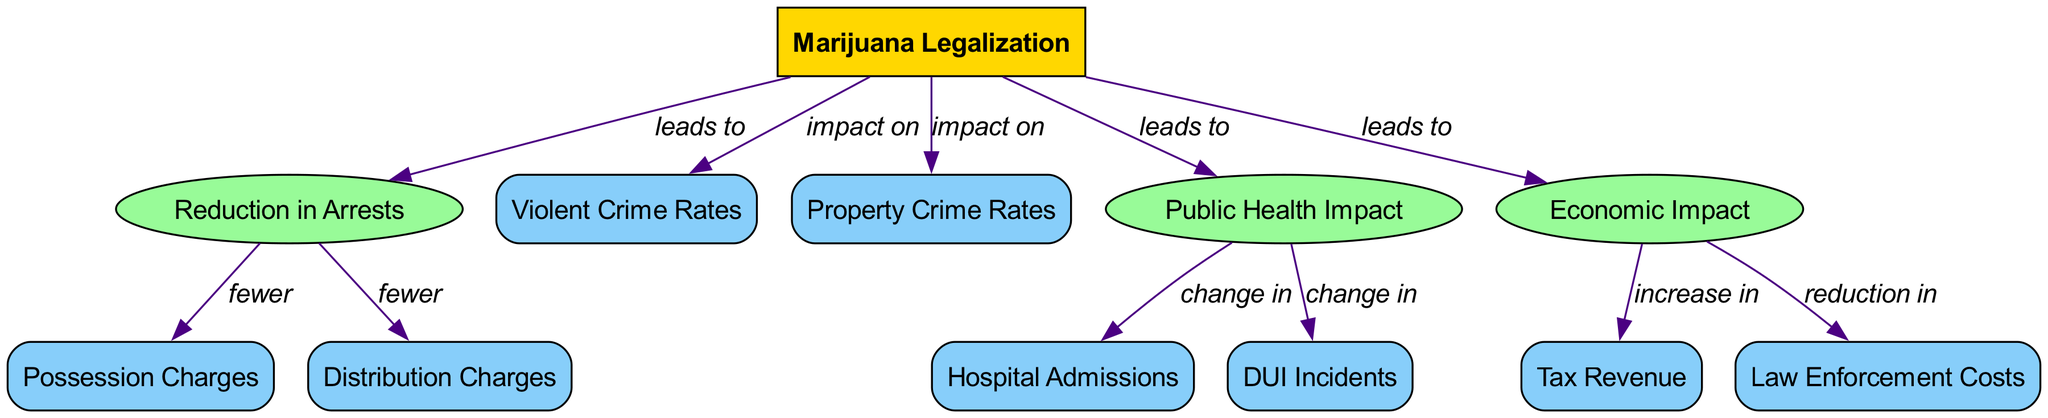What is the main topic of the diagram? The main topic is indicated as "Marijuana Legalization," which is the starting point from where all the other nodes stem. It is visually separated from other nodes that show consequences and data related to the impacts of legalization.
Answer: Marijuana Legalization How many consequences are linked to marijuana legalization? By examining the diagram, we can see three key consequences branching out from the "Marijuana Legalization" node: "Reduction in Arrests," "Public Health Impact," and "Economic Impact." Thus, the count is straightforward.
Answer: 3 What is indicated to happen to possession charges after marijuana legalization? The diagram states that there will be "fewer" possession charges as a direct consequence of marijuana legalization according to the edge labeling. Thus, it indicates a reduction.
Answer: Fewer What are the two types of crime impacted by marijuana legalization? The diagram lists "Violent Crime Rates" and "Property Crime Rates" as data points that are affected by marijuana legalization, connected by edges labeled "impact on."
Answer: Violent Crime Rates and Property Crime Rates What change occurs in hospital admissions due to public health impact? The diagram indicates that there is a "change in" hospital admissions as a consequence of public health impact stemming from marijuana legalization, showing that some shifts will take place.
Answer: Change in How does marijuana legalization affect tax revenue? Looking at the diagram, it indicates that marijuana legalization leads to an "increase in" tax revenue as part of the economic impacts, making a causal relationship clear.
Answer: Increase in How many data nodes are displayed in the diagram? The diagram consists of six data nodes: "Possession Charges," "Distribution Charges," "Violent Crime Rates," "Property Crime Rates," "Hospital Admissions," and "DUI Incidents." Counting these provides the answer.
Answer: 6 What is the relationship between economic impact and law enforcement costs? The diagram shows that the economic impact leads to a "reduction in" law enforcement costs, illustrating a specific economic consequence of legalization.
Answer: Reduction in What is the flow of information after marijuana legalization concerning arrests? According to the diagram, marijuana legalization leads to a reduction in arrests, resulting in fewer possession and distribution charges, demonstrating a cascade of consequences starting from the main topic.
Answer: Reduction in Arrests leading to Fewer Possession and Distribution Charges 